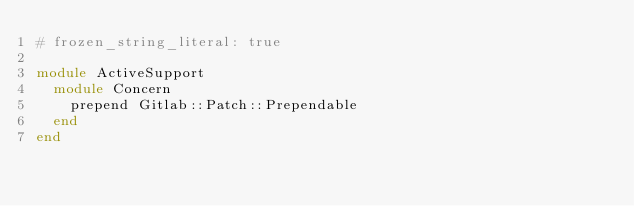<code> <loc_0><loc_0><loc_500><loc_500><_Ruby_># frozen_string_literal: true

module ActiveSupport
  module Concern
    prepend Gitlab::Patch::Prependable
  end
end
</code> 